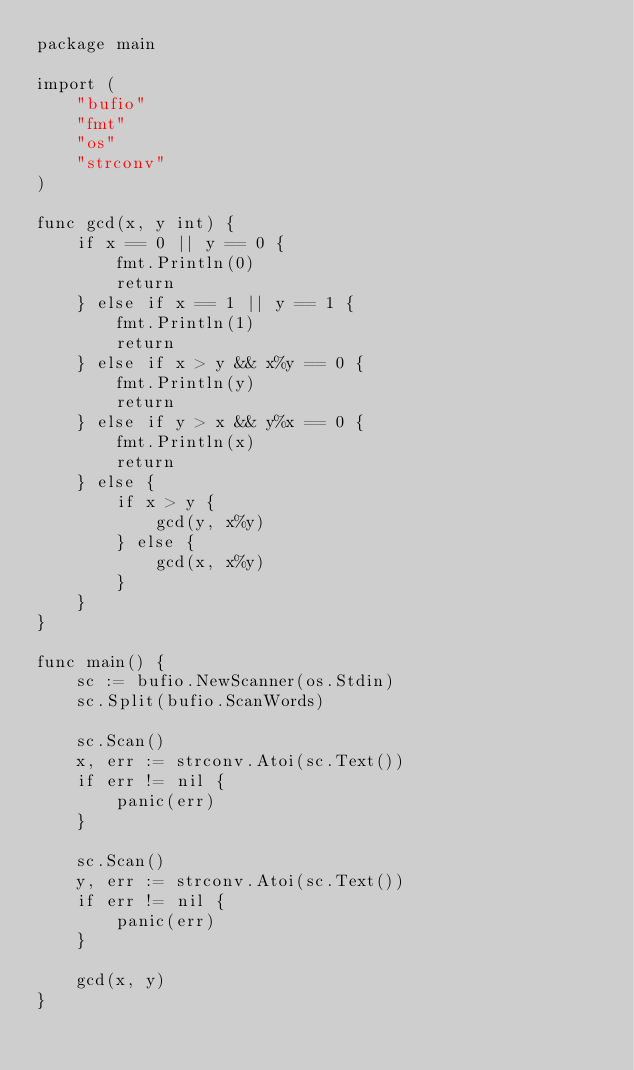Convert code to text. <code><loc_0><loc_0><loc_500><loc_500><_Go_>package main

import (
	"bufio"
	"fmt"
	"os"
	"strconv"
)

func gcd(x, y int) {
	if x == 0 || y == 0 {
		fmt.Println(0)
		return
	} else if x == 1 || y == 1 {
		fmt.Println(1)
		return
	} else if x > y && x%y == 0 {
		fmt.Println(y)
		return
	} else if y > x && y%x == 0 {
		fmt.Println(x)
		return
	} else {
		if x > y {
			gcd(y, x%y)
		} else {
			gcd(x, x%y)
		}
	}
}

func main() {
	sc := bufio.NewScanner(os.Stdin)
	sc.Split(bufio.ScanWords)

	sc.Scan()
	x, err := strconv.Atoi(sc.Text())
	if err != nil {
		panic(err)
	}

	sc.Scan()
	y, err := strconv.Atoi(sc.Text())
	if err != nil {
		panic(err)
	}

	gcd(x, y)
}

</code> 